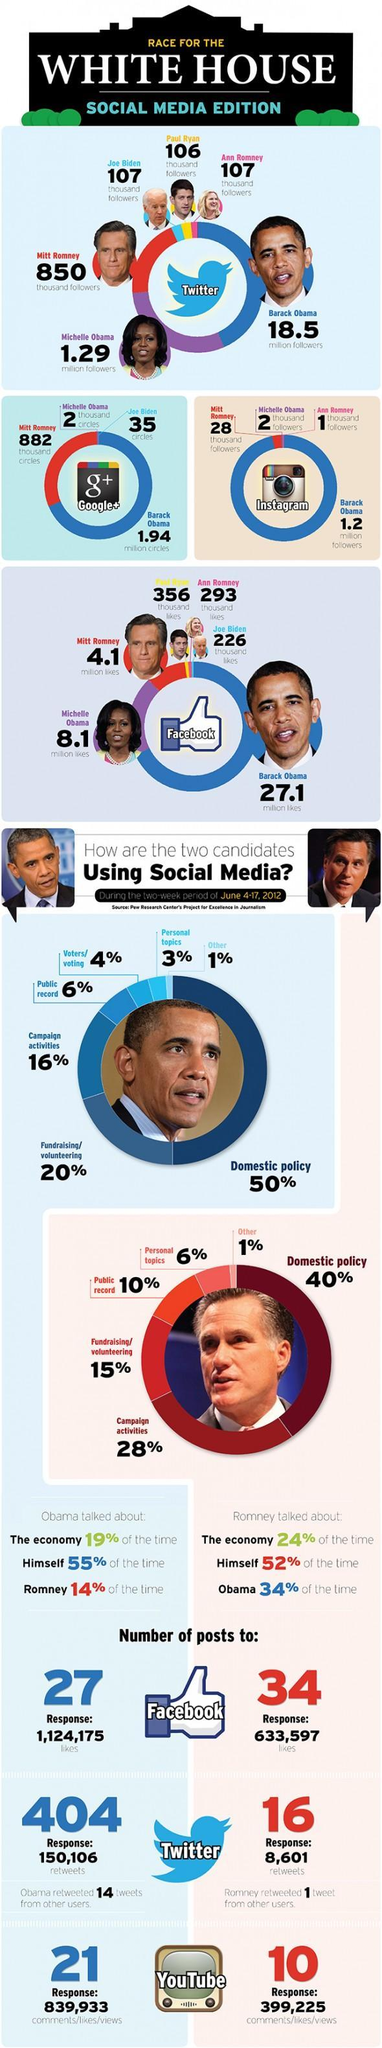Who has the third largest number of Instagram followers in Whitehouse?
Answer the question with a short phrase. Michelle Obama what percent of time Romney talked about himself or Obama in social media? 86% who posted more to Twitter during the period according to this infographic? Obama what is the number of likes received by Barack Obama and Michelle Obama in millions on Facebook? 35.2 who posted more to YouTube during the period according to this infographic? Obama who posted more to Facebook during the period according to this infographic? Romney who has spend more of their social media time for speaking about economy? Romney Who has the third largest number of Twitter followers in Whitehouse? Mitt Romney Who has the second largest number of Twitter followers in Whitehouse? Michelle Obama in which platform Barack Obama has more followers - twitter or Instagram? Twitter What percent of social media time Romney spent for fund raising, volunteering or campaigning? 44 Who has the second largest number of Instagram followers in Whitehouse? Mitt Romney what percent of social media time Romney spend for other than domestic policy? 60 what percent of time Obama talked about himself or Romney in social media? 69% What percent of social media time Obama spent for fund raising, volunteering or campaigning? 36% 